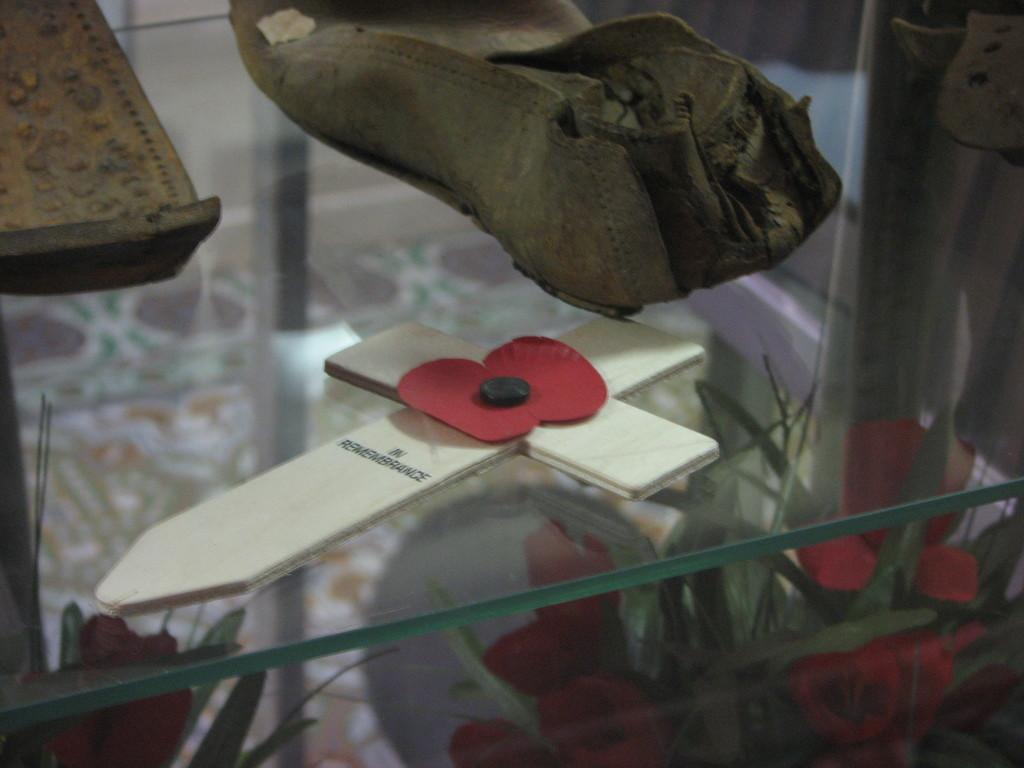What is on the glass table in the image? The facts do not specify the objects on the glass table, so we cannot answer this question definitively. What type of plants are visible in the image? There are plants with flowers below the table in the image. What type of stitch is used to create the quilt on the hall table in the image? There is no quilt or hall table present in the image, so it is not possible to answer that question. 